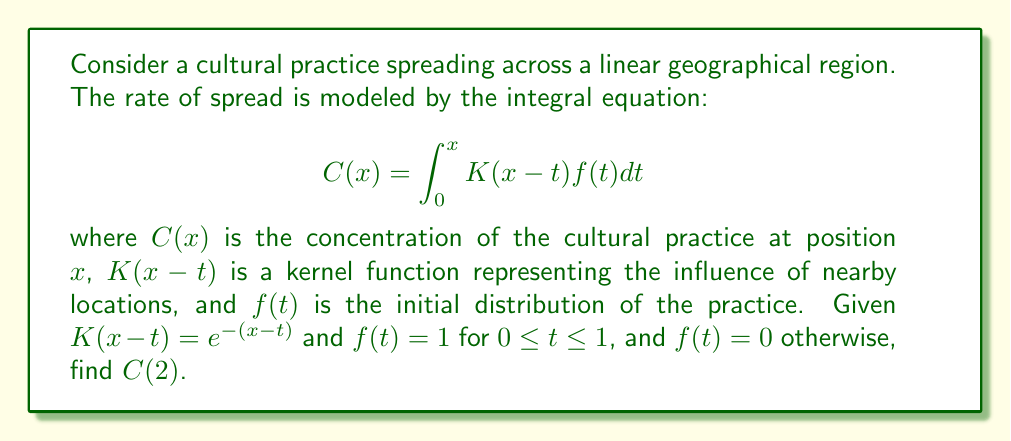Provide a solution to this math problem. To solve this problem, we'll follow these steps:

1) First, we need to set up the integral with the given information:
   $$C(2) = \int_0^2 e^{-(2-t)} \cdot f(t) dt$$

2) We know that $f(t) = 1$ for $0 \leq t \leq 1$, and $f(t) = 0$ otherwise. So we can split the integral:
   $$C(2) = \int_0^1 e^{-(2-t)} \cdot 1 dt + \int_1^2 e^{-(2-t)} \cdot 0 dt$$

3) The second integral becomes zero, so we're left with:
   $$C(2) = \int_0^1 e^{-(2-t)} dt$$

4) To solve this, let's substitute $u = 2-t$, so $du = -dt$:
   $$C(2) = -\int_2^1 e^{-u} (-du) = \int_2^1 e^{-u} du$$

5) Now we can integrate:
   $$C(2) = [-e^{-u}]_2^1 = -e^{-1} - (-e^{-2})$$

6) Simplify:
   $$C(2) = e^{-2} - e^{-1}$$

7) This can be further simplified:
   $$C(2) = \frac{1}{e^2} - \frac{1}{e} = \frac{1}{e^2} - \frac{e}{e^2} = \frac{1-e}{e^2}$$
Answer: $\frac{1-e}{e^2}$ 